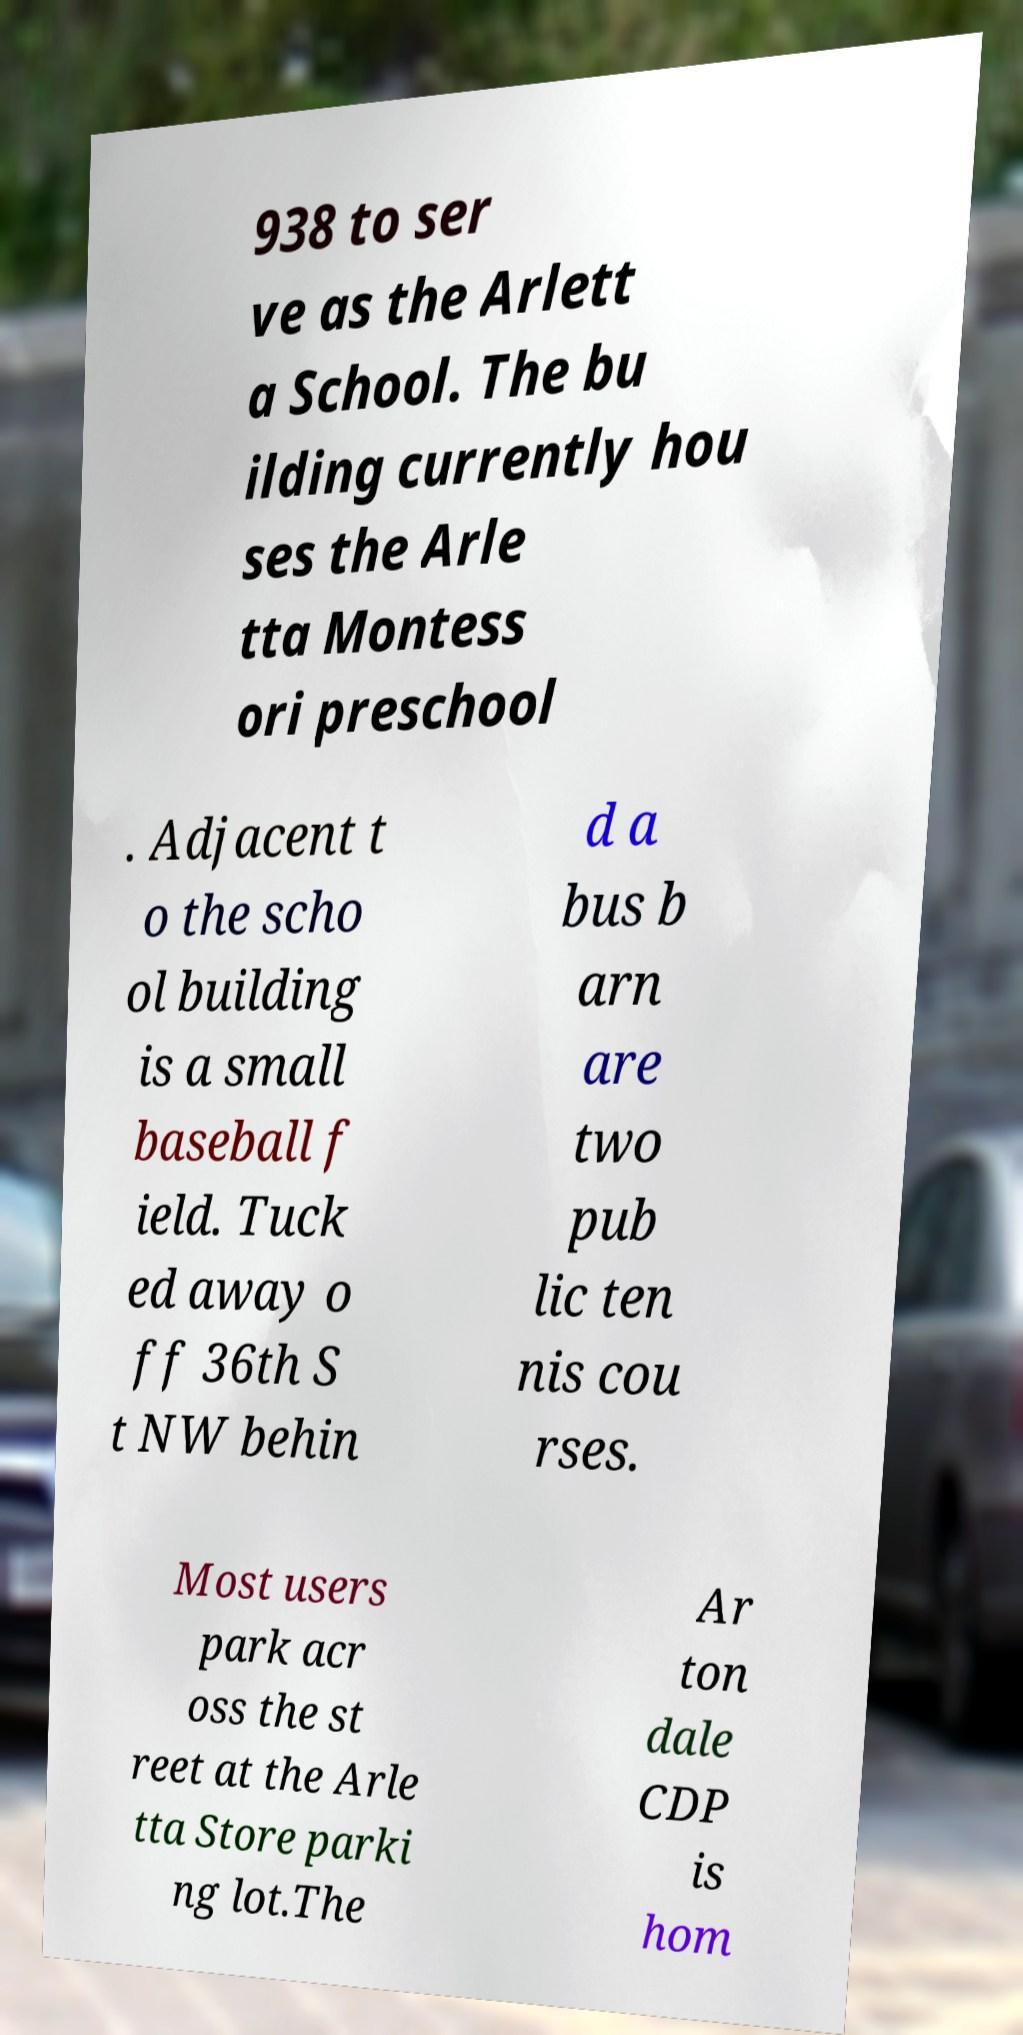Can you accurately transcribe the text from the provided image for me? 938 to ser ve as the Arlett a School. The bu ilding currently hou ses the Arle tta Montess ori preschool . Adjacent t o the scho ol building is a small baseball f ield. Tuck ed away o ff 36th S t NW behin d a bus b arn are two pub lic ten nis cou rses. Most users park acr oss the st reet at the Arle tta Store parki ng lot.The Ar ton dale CDP is hom 